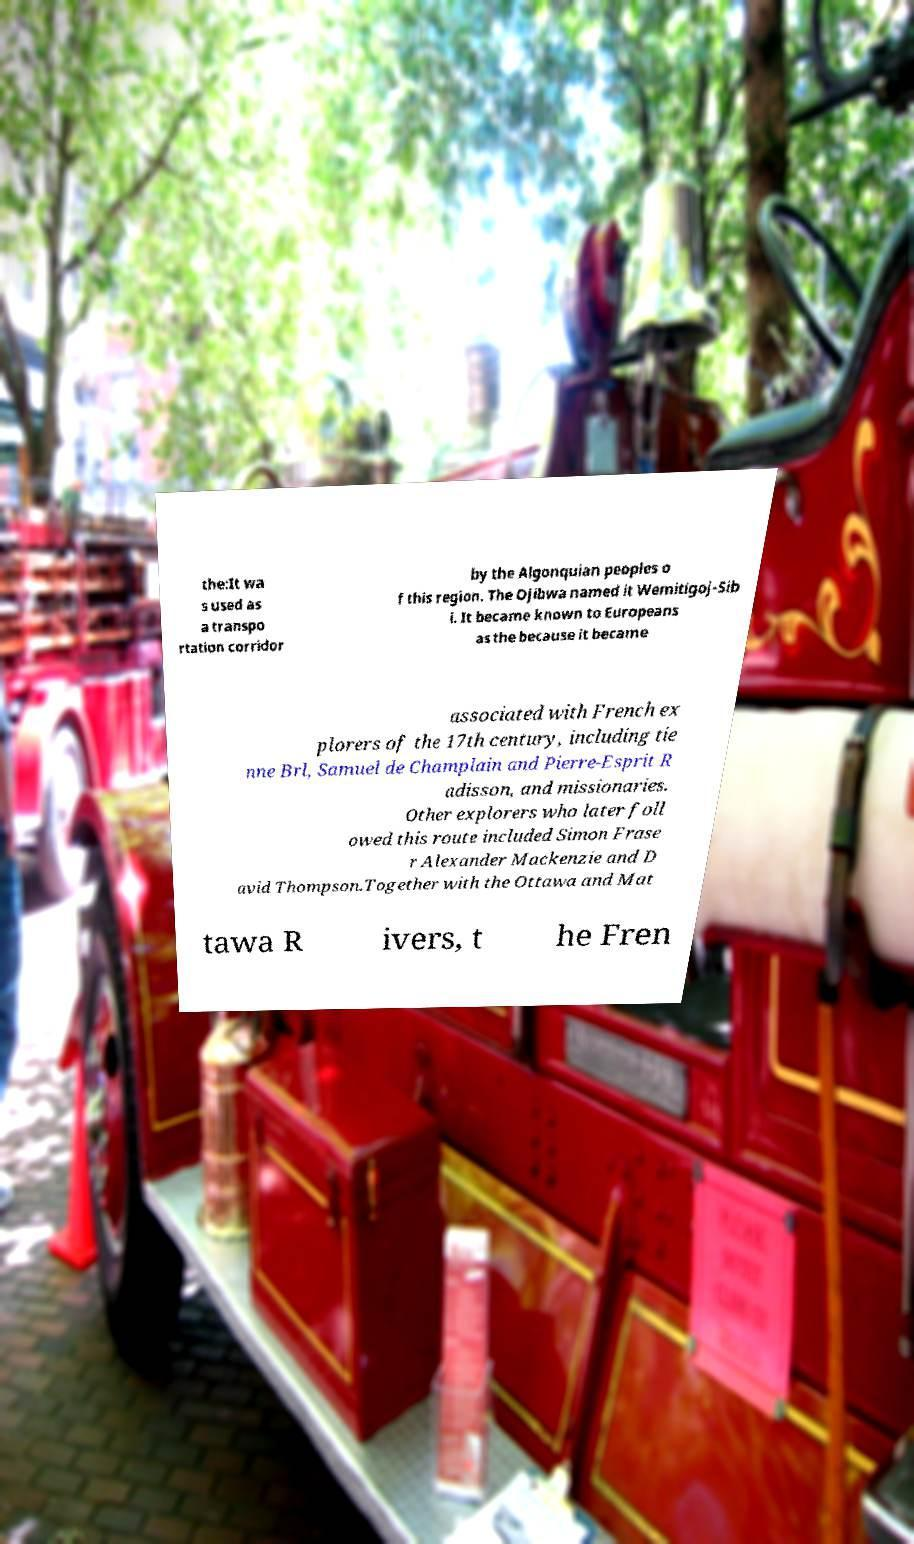What messages or text are displayed in this image? I need them in a readable, typed format. the:It wa s used as a transpo rtation corridor by the Algonquian peoples o f this region. The Ojibwa named it Wemitigoj-Sib i. It became known to Europeans as the because it became associated with French ex plorers of the 17th century, including tie nne Brl, Samuel de Champlain and Pierre-Esprit R adisson, and missionaries. Other explorers who later foll owed this route included Simon Frase r Alexander Mackenzie and D avid Thompson.Together with the Ottawa and Mat tawa R ivers, t he Fren 